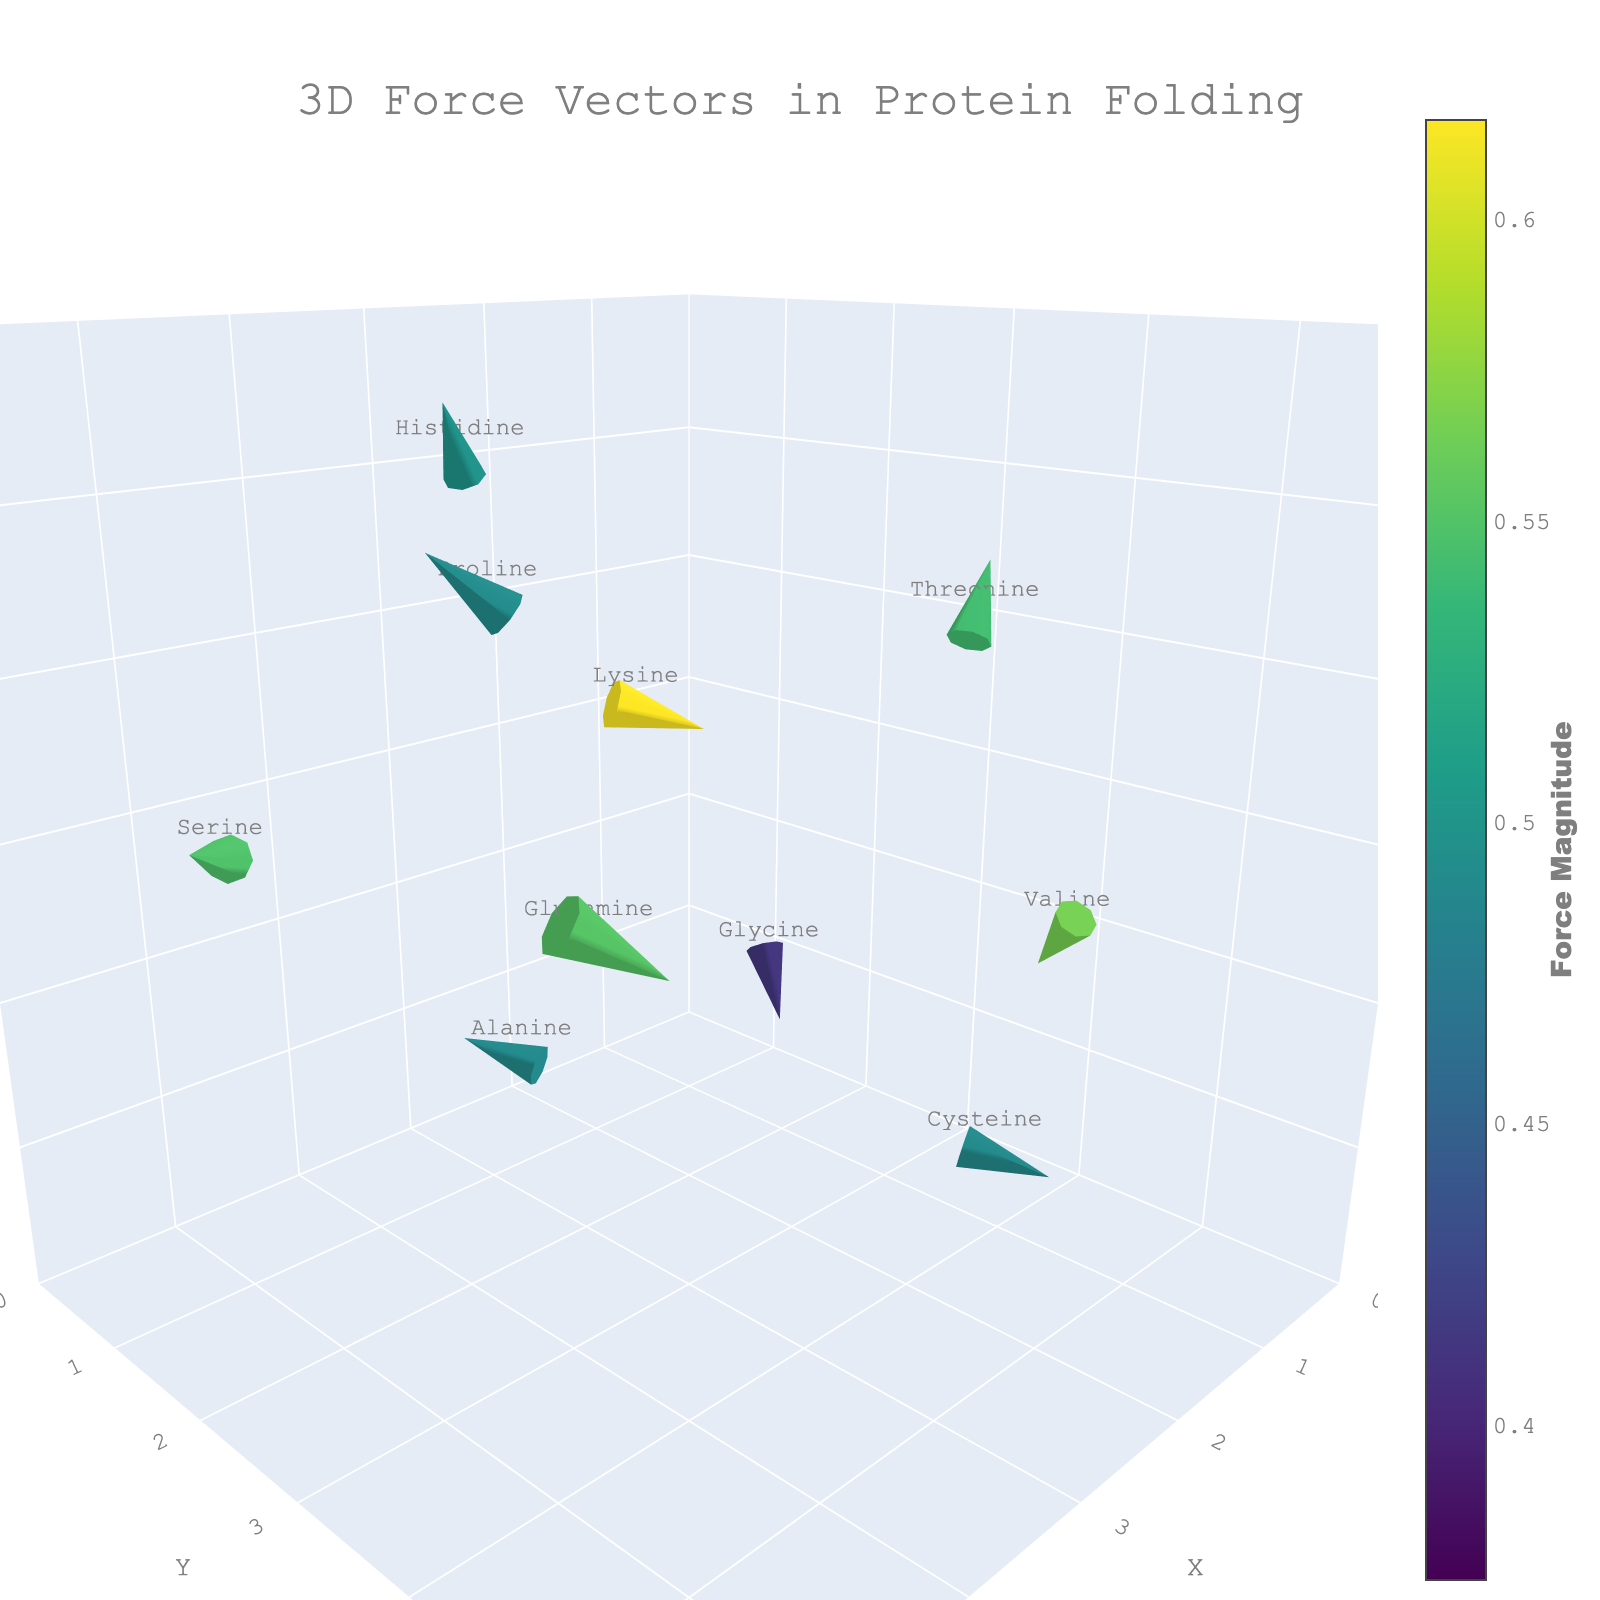What is the title of the figure? The title is usually displayed prominently at the top of the figure. In this case, it states "3D Force Vectors in Protein Folding".
Answer: 3D Force Vectors in Protein Folding What is the range of the X-axis? The X-axis range can be seen along the X-axis markings in the figure. The code specifies it ranges from 0 to 6.
Answer: 0 to 6 Which amino acid has the highest force magnitude? To find the highest force magnitude, compare all the values of 'force_magnitude'. From the data, both Serine and Glutamine have a force magnitude of 0.54.
Answer: Serine and Glutamine How many force vectors are displayed in the plot? The number of force vectors corresponds to the number of data points in the dataset. This can be counted directly from the data list, which contains 10 entries.
Answer: 10 Which amino acids have a negative X-component of force? The X-component of force is given by 'u'. By examining the data, Lysine, Threonine, Cysteine, Valine, and Glutamine have negative values for 'u'.
Answer: Lysine, Threonine, Cysteine, Valine, Glutamine Which amino acid is located at the coordinates (4.1, 2.7, 1.9)? By locating the coordinates (4.1, 2.7, 1.9) within the data, the corresponding amino acid is Alanine.
Answer: Alanine Out of Glycine and Histidine, which has a larger force magnitude? Compare the force magnitudes: Glycine (0.37) and Histidine (0.45). Histidine has a larger force magnitude.
Answer: Histidine What is the average force magnitude of all amino acids? Sum all force magnitudes and then divide by the number of amino acids. The sum is 4.91 and there are 10 amino acids. Average = 4.91/10 = 0.491.
Answer: 0.491 Which amino acid's force vector has the highest Z-component? The Z-component of force is given by 'w'. Among the 'w' values, Threonine has the highest with a value of 0.4.
Answer: Threonine Which two amino acids have vectors pointing in the negative Y direction? The Y-component of force is given by 'v'. Lysine and Proline have negative values for 'v' (-0.4 and -0.2, respectively).
Answer: Lysine and Proline 